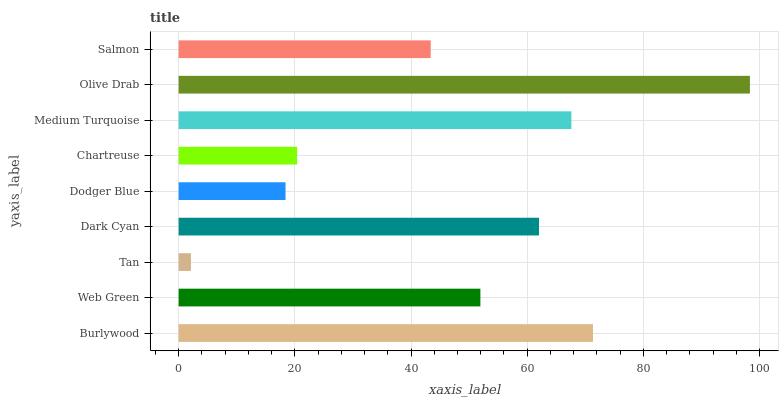Is Tan the minimum?
Answer yes or no. Yes. Is Olive Drab the maximum?
Answer yes or no. Yes. Is Web Green the minimum?
Answer yes or no. No. Is Web Green the maximum?
Answer yes or no. No. Is Burlywood greater than Web Green?
Answer yes or no. Yes. Is Web Green less than Burlywood?
Answer yes or no. Yes. Is Web Green greater than Burlywood?
Answer yes or no. No. Is Burlywood less than Web Green?
Answer yes or no. No. Is Web Green the high median?
Answer yes or no. Yes. Is Web Green the low median?
Answer yes or no. Yes. Is Chartreuse the high median?
Answer yes or no. No. Is Dodger Blue the low median?
Answer yes or no. No. 